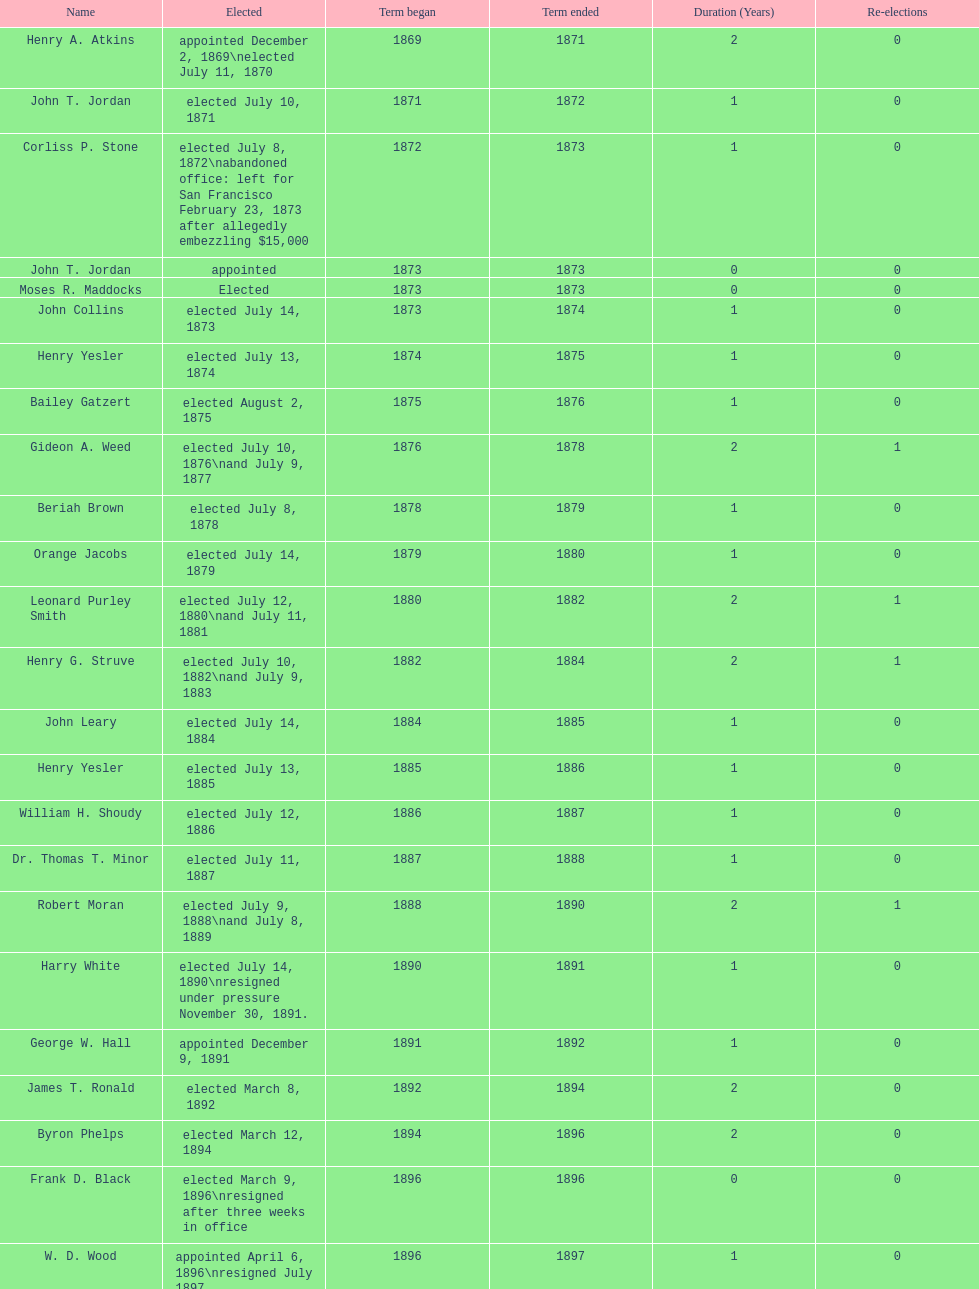Who held the position of mayor prior to jordan? Henry A. Atkins. 